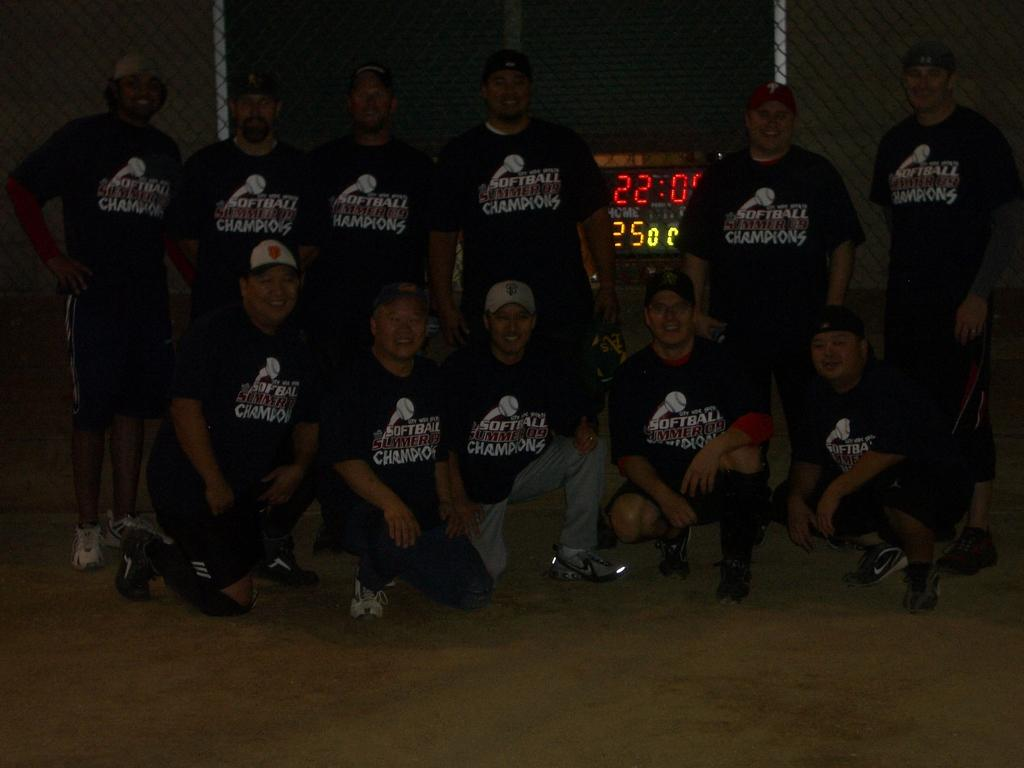<image>
Offer a succinct explanation of the picture presented. Several men wearing black shirts that say Summer Softball Champions are in two rows, posing for a photo. 